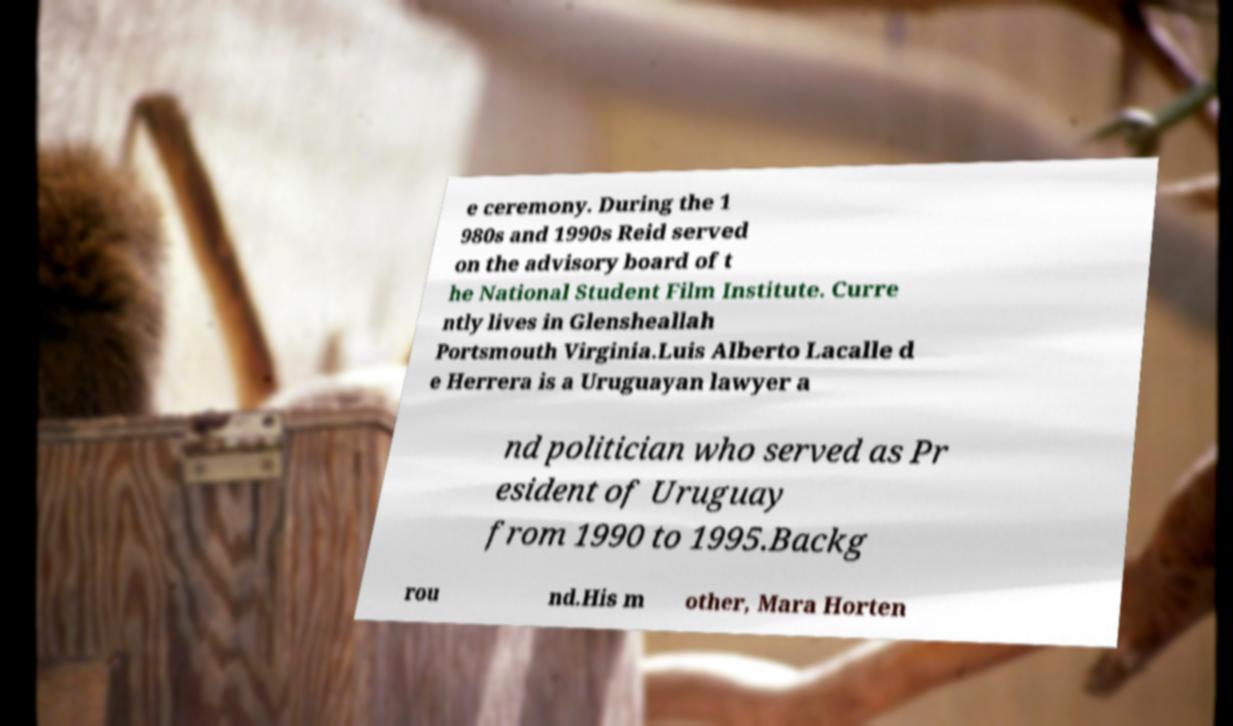Can you accurately transcribe the text from the provided image for me? e ceremony. During the 1 980s and 1990s Reid served on the advisory board of t he National Student Film Institute. Curre ntly lives in Glensheallah Portsmouth Virginia.Luis Alberto Lacalle d e Herrera is a Uruguayan lawyer a nd politician who served as Pr esident of Uruguay from 1990 to 1995.Backg rou nd.His m other, Mara Horten 